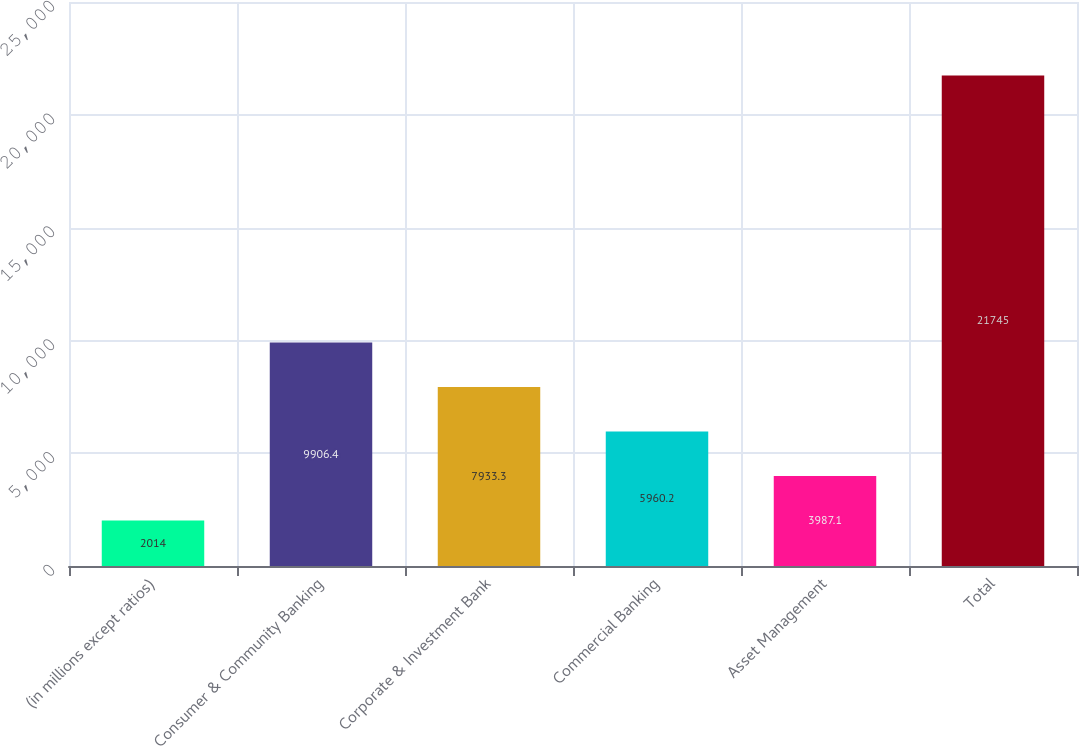<chart> <loc_0><loc_0><loc_500><loc_500><bar_chart><fcel>(in millions except ratios)<fcel>Consumer & Community Banking<fcel>Corporate & Investment Bank<fcel>Commercial Banking<fcel>Asset Management<fcel>Total<nl><fcel>2014<fcel>9906.4<fcel>7933.3<fcel>5960.2<fcel>3987.1<fcel>21745<nl></chart> 